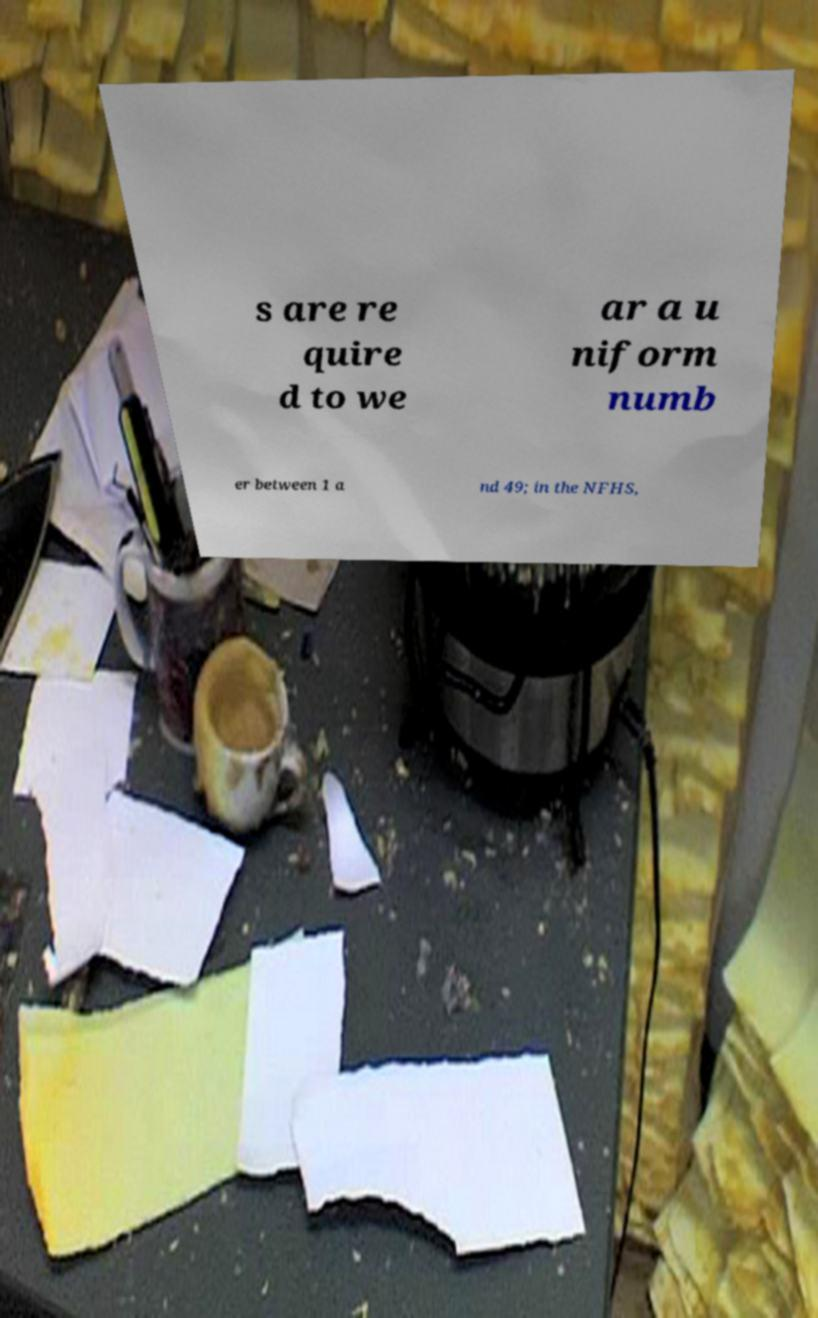Could you extract and type out the text from this image? s are re quire d to we ar a u niform numb er between 1 a nd 49; in the NFHS, 